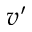<formula> <loc_0><loc_0><loc_500><loc_500>v ^ { \prime }</formula> 